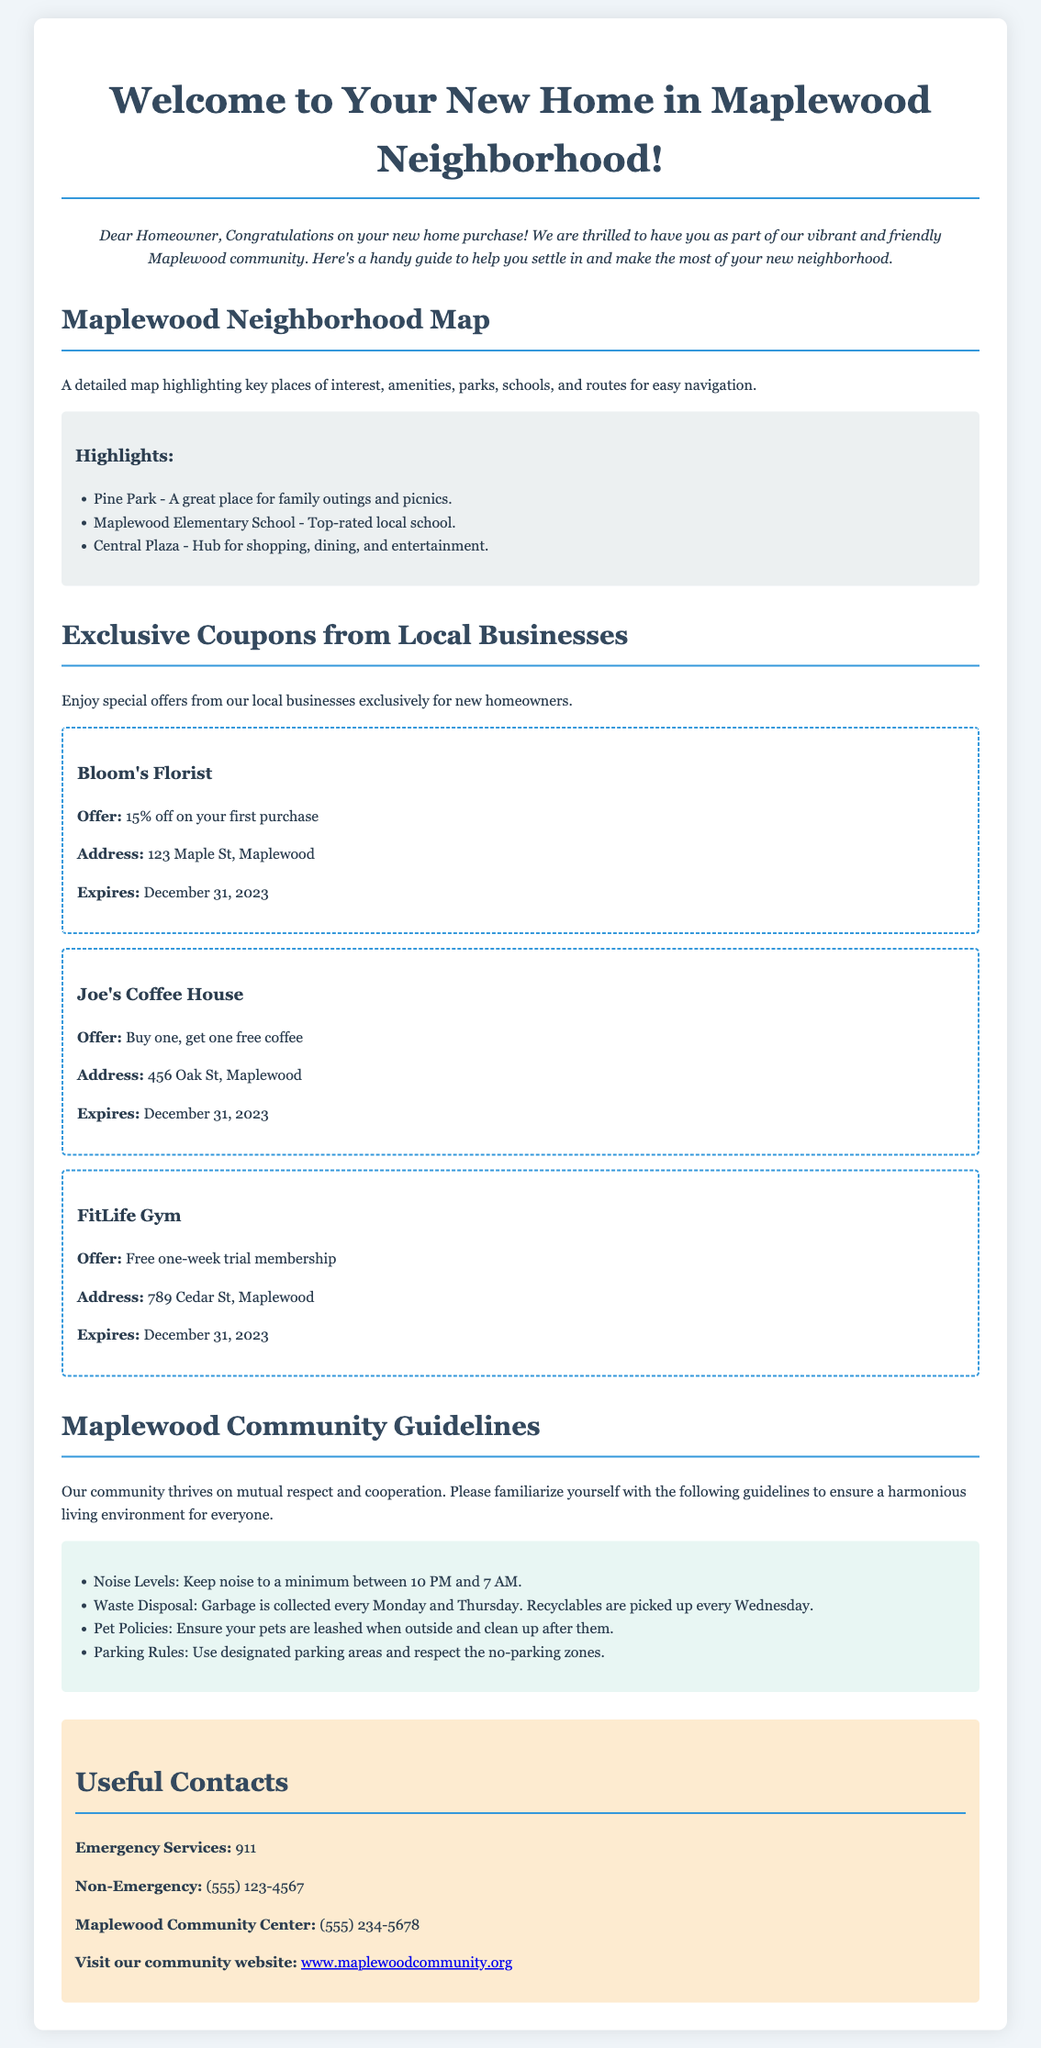What is the title of the document? The title of the document is found in the `<title>` tag, which indicates the main subject of the content.
Answer: Welcome to Maplewood Neighborhood What is the offer from Bloom's Florist? The offer details are provided under the coupon section for Bloom's Florist, specifying the discount available.
Answer: 15% off on your first purchase What are the park's name mentioned in highlights? The park's name is listed in the map highlights section, which indicates important local attractions.
Answer: Pine Park What is the community's guideline regarding noise? The guideline regarding noise is specified among other community practices to promote respectful living.
Answer: Keep noise to a minimum between 10 PM and 7 AM What is the address of Joe's Coffee House? The address is listed under the coupon information for Joe's Coffee House.
Answer: 456 Oak St, Maplewood How long is the trial membership at FitLife Gym? The duration of the trial membership offered is provided in the description of the coupon from FitLife Gym.
Answer: One week What is the contact number for the Maplewood Community Center? The contact information for local services, including the Maplewood Community Center, is presented in the useful contacts section.
Answer: (555) 234-5678 When does garbage collection occur? The waste disposal schedule is outlined in the community guidelines for residents to follow.
Answer: Every Monday and Thursday How many local businesses are featured in the coupons section? The number of businesses in the coupon section can be counted directly from the content provided.
Answer: Three 